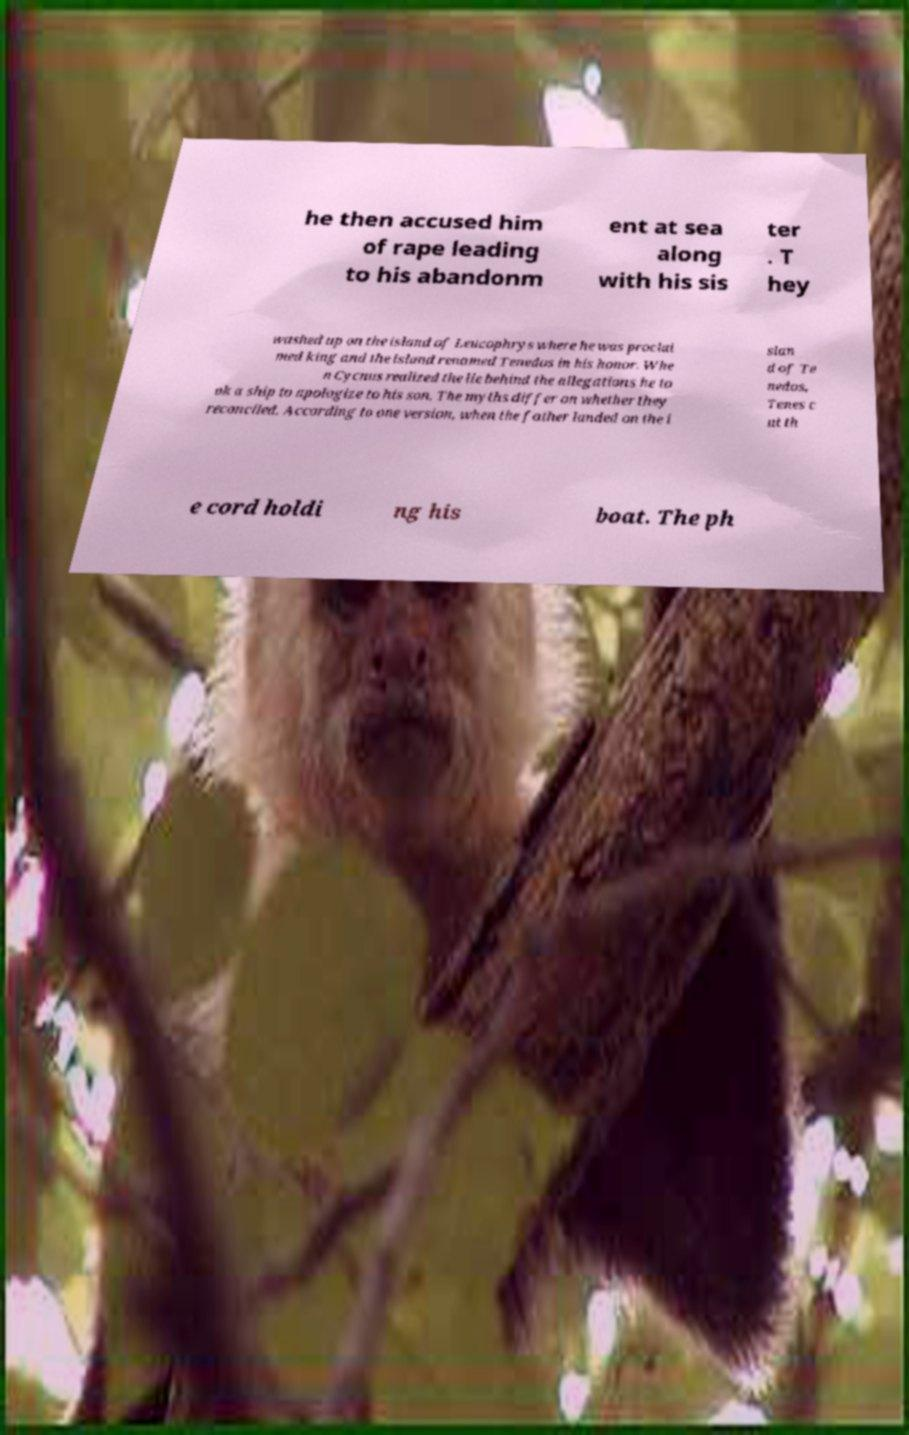Please identify and transcribe the text found in this image. he then accused him of rape leading to his abandonm ent at sea along with his sis ter . T hey washed up on the island of Leucophrys where he was proclai med king and the island renamed Tenedos in his honor. Whe n Cycnus realized the lie behind the allegations he to ok a ship to apologize to his son. The myths differ on whether they reconciled. According to one version, when the father landed on the i slan d of Te nedos, Tenes c ut th e cord holdi ng his boat. The ph 